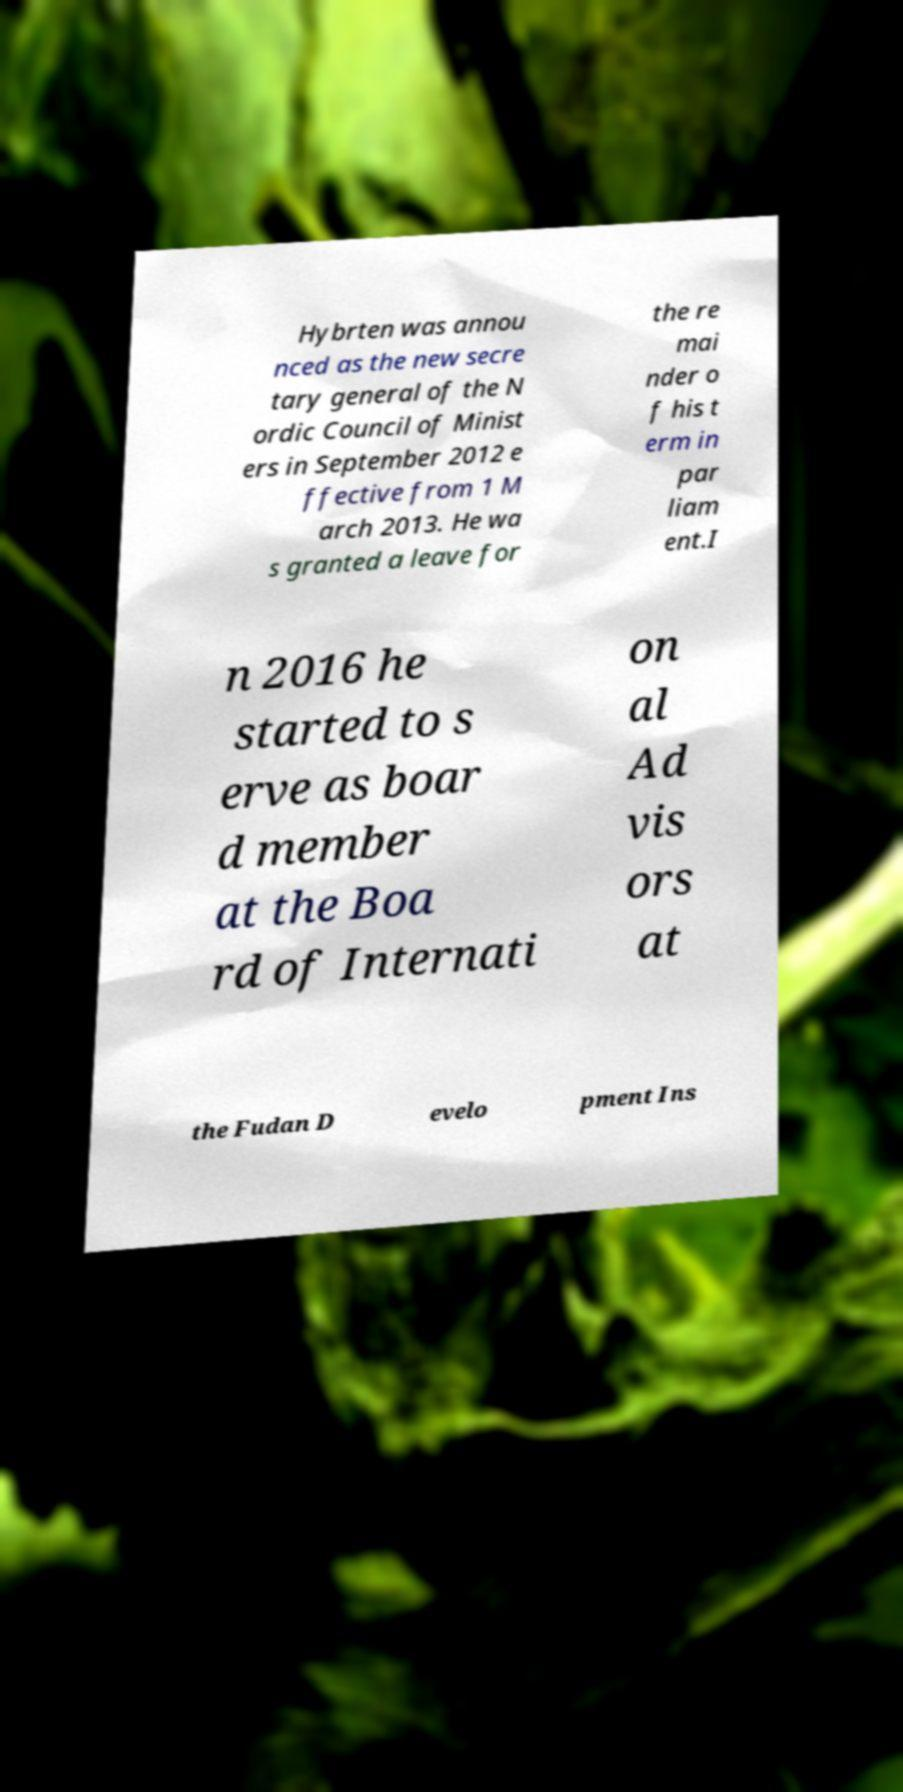Can you accurately transcribe the text from the provided image for me? Hybrten was annou nced as the new secre tary general of the N ordic Council of Minist ers in September 2012 e ffective from 1 M arch 2013. He wa s granted a leave for the re mai nder o f his t erm in par liam ent.I n 2016 he started to s erve as boar d member at the Boa rd of Internati on al Ad vis ors at the Fudan D evelo pment Ins 